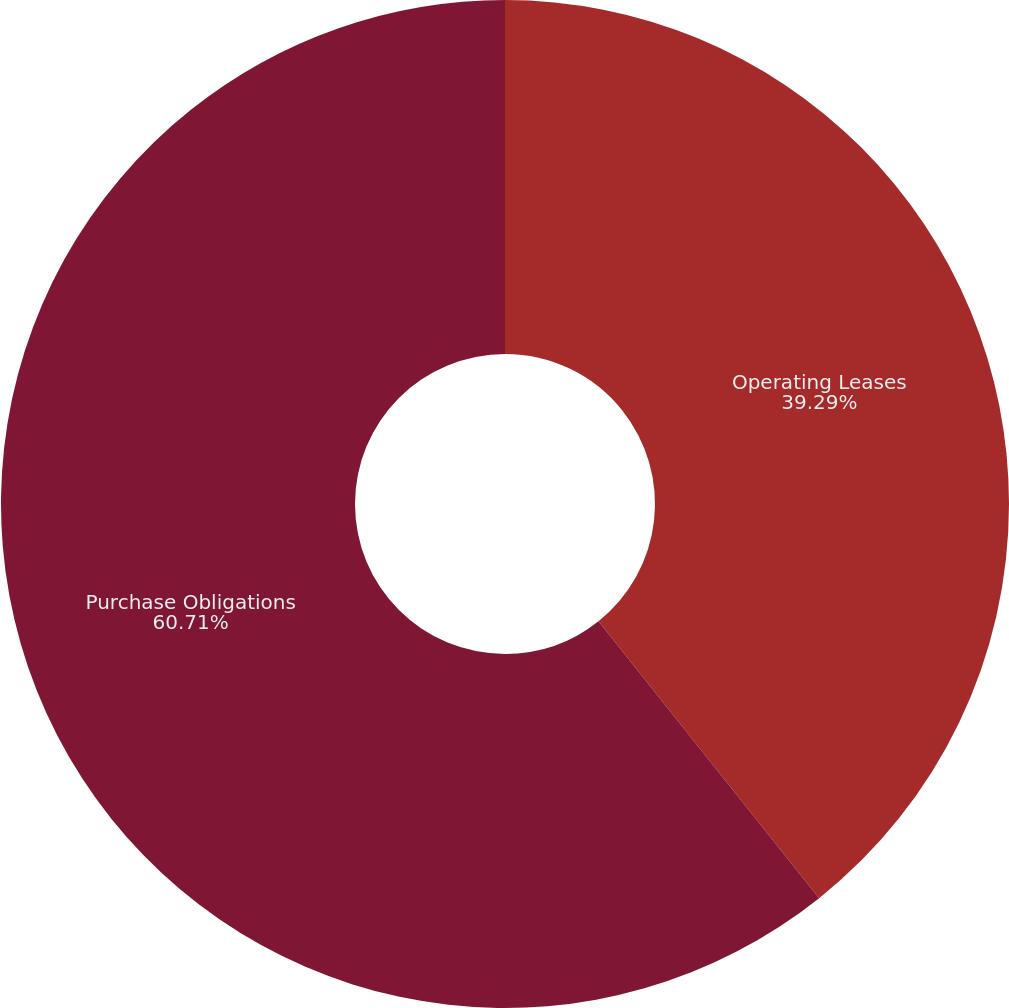Convert chart to OTSL. <chart><loc_0><loc_0><loc_500><loc_500><pie_chart><fcel>Operating Leases<fcel>Purchase Obligations<nl><fcel>39.29%<fcel>60.71%<nl></chart> 